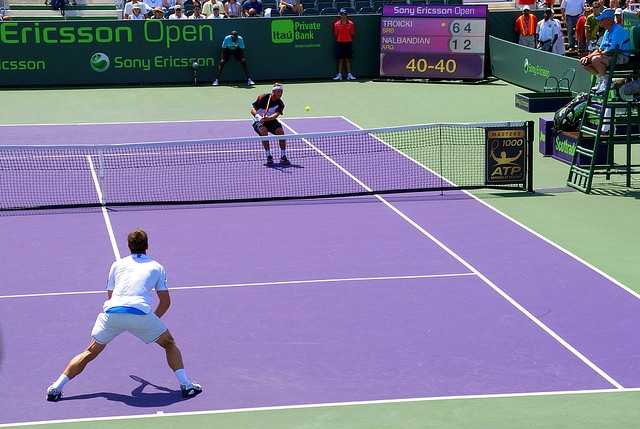Describe the objects in this image and their specific colors. I can see people in gray, white, maroon, and darkgray tones, chair in gray, black, darkgray, and teal tones, people in gray, black, navy, and white tones, people in gray, black, maroon, blue, and violet tones, and people in gray, black, maroon, and blue tones in this image. 